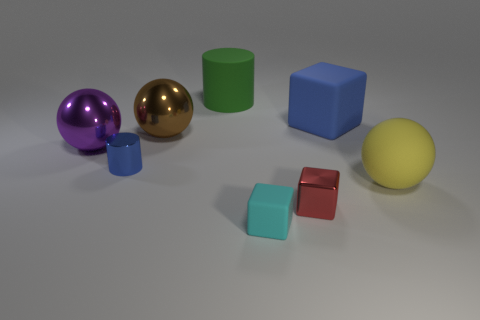What textures are visible amongst the various objects? The objects in the image display a variety of textures. The two spheres and the tall cylinder have a polished, shiny texture, indicating they might be metallic. The cubes and the smaller cylinder have a matte texture, suggesting they could be made of rubber or a similar non-reflective material. 